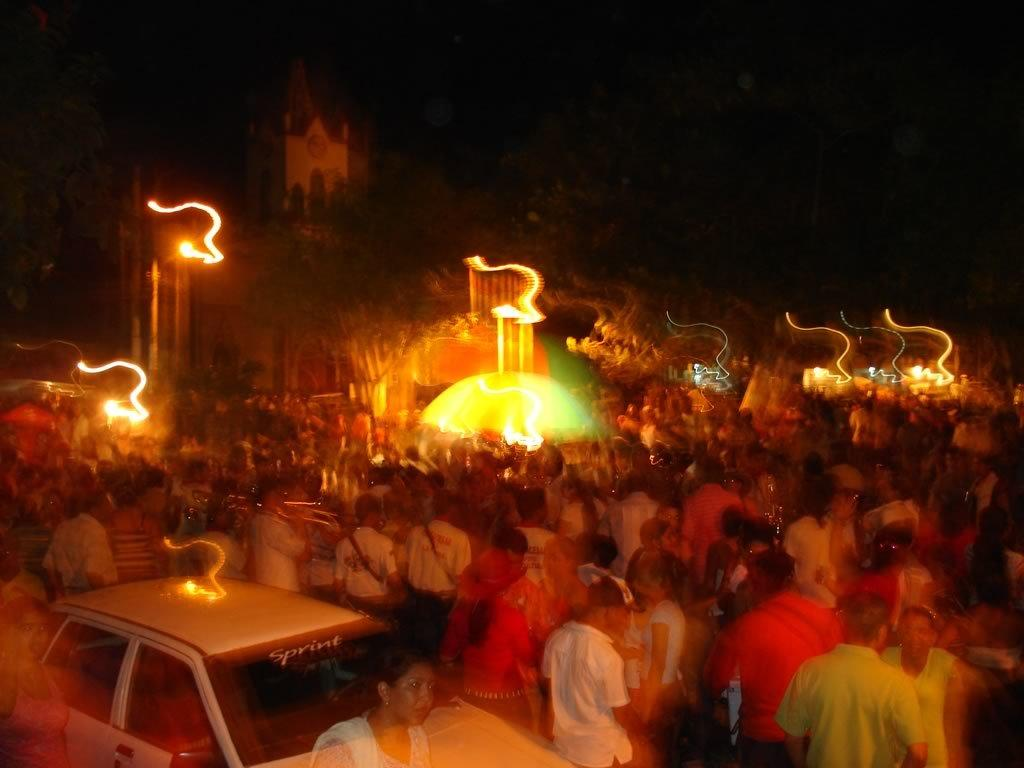How many people are in the image? There is a group of people in the image. What are the people doing in the image? The people are on a path. What else can be seen in the image besides the group of people? There is a vehicle in the image. What is visible in the background of the image? There is a building in the background of the image, and the background is dark. What language are the people speaking in the image? There is no information about the language spoken by the people in the image. 